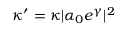Convert formula to latex. <formula><loc_0><loc_0><loc_500><loc_500>\kappa ^ { \prime } = \kappa | \alpha _ { 0 } e ^ { \gamma } | ^ { 2 }</formula> 